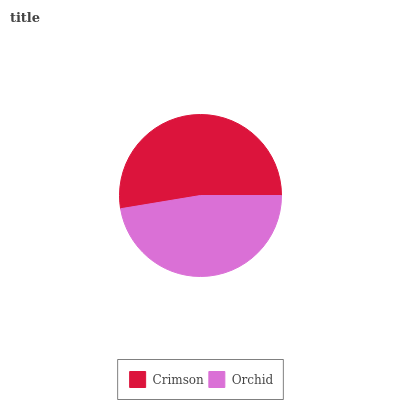Is Orchid the minimum?
Answer yes or no. Yes. Is Crimson the maximum?
Answer yes or no. Yes. Is Orchid the maximum?
Answer yes or no. No. Is Crimson greater than Orchid?
Answer yes or no. Yes. Is Orchid less than Crimson?
Answer yes or no. Yes. Is Orchid greater than Crimson?
Answer yes or no. No. Is Crimson less than Orchid?
Answer yes or no. No. Is Crimson the high median?
Answer yes or no. Yes. Is Orchid the low median?
Answer yes or no. Yes. Is Orchid the high median?
Answer yes or no. No. Is Crimson the low median?
Answer yes or no. No. 